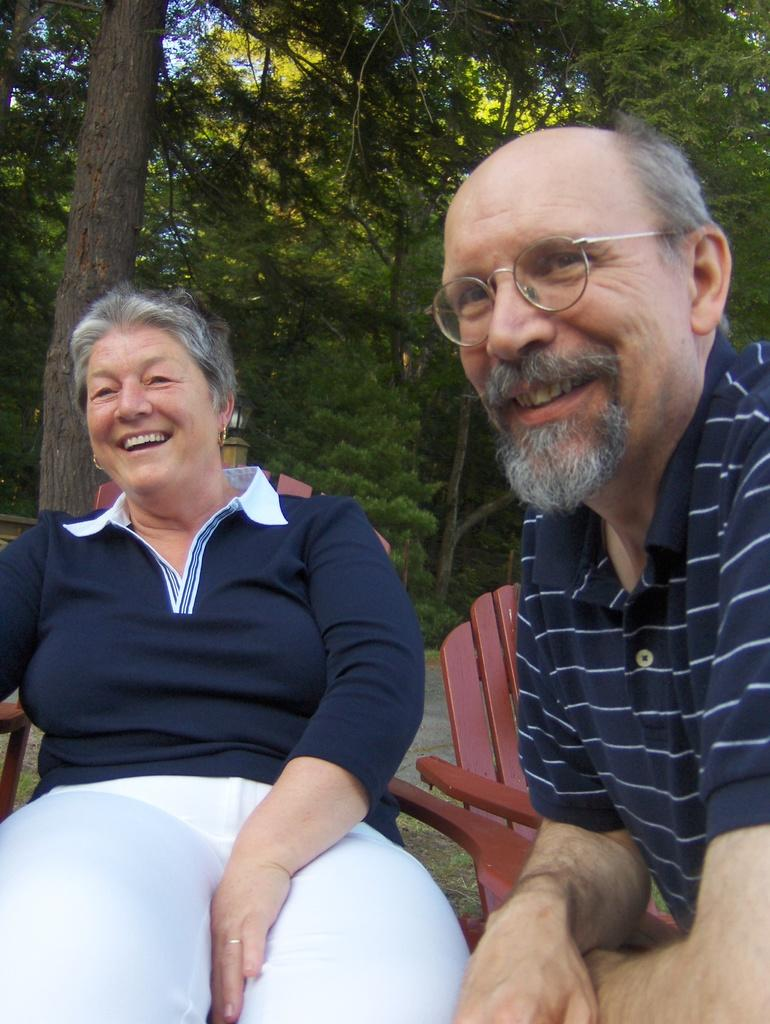How many people are in the image? There are two people in the image, a woman and a man. What are the woman and man doing in the image? The woman and man are seated on chairs and smiling. What can be seen in the background of the image? There are trees in the background of the image. What type of oven is visible in the image? There is no oven present in the image. What is the cannon used for in the image? There is no cannon present in the image. 